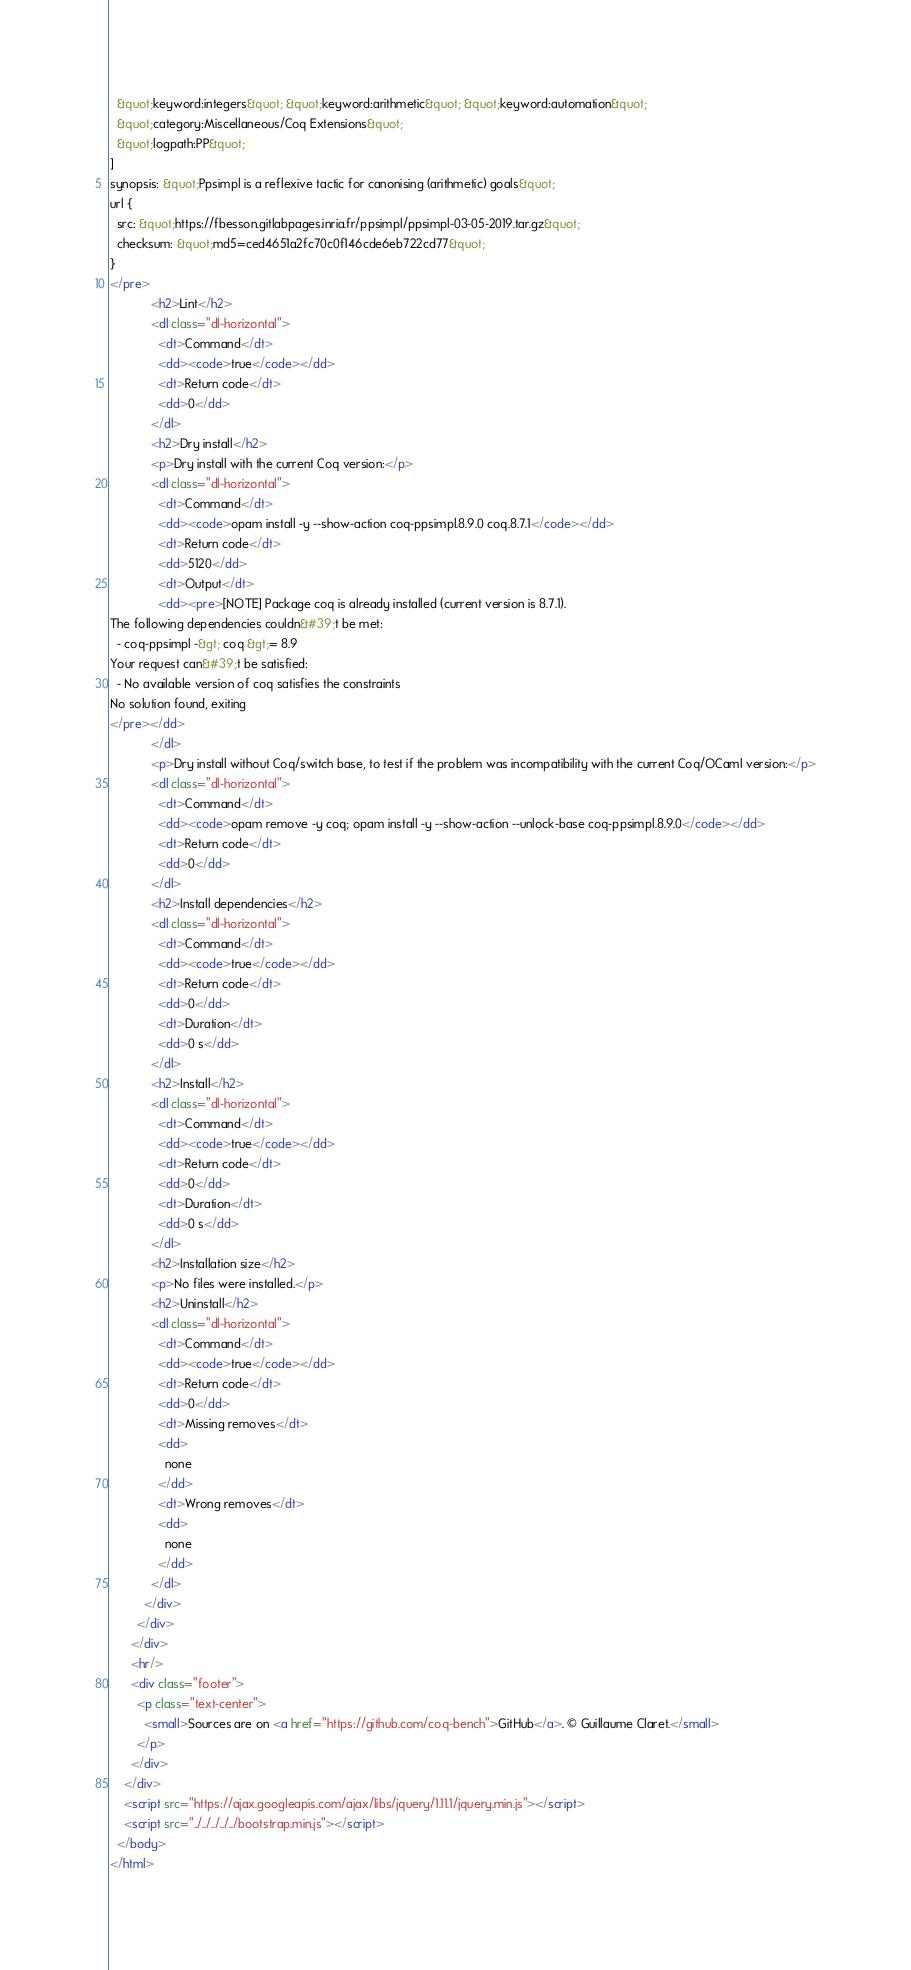Convert code to text. <code><loc_0><loc_0><loc_500><loc_500><_HTML_>  &quot;keyword:integers&quot; &quot;keyword:arithmetic&quot; &quot;keyword:automation&quot;
  &quot;category:Miscellaneous/Coq Extensions&quot;
  &quot;logpath:PP&quot;
]
synopsis: &quot;Ppsimpl is a reflexive tactic for canonising (arithmetic) goals&quot;
url {
  src: &quot;https://fbesson.gitlabpages.inria.fr/ppsimpl/ppsimpl-03-05-2019.tar.gz&quot;
  checksum: &quot;md5=ced4651a2fc70c0f146cde6eb722cd77&quot;
}
</pre>
            <h2>Lint</h2>
            <dl class="dl-horizontal">
              <dt>Command</dt>
              <dd><code>true</code></dd>
              <dt>Return code</dt>
              <dd>0</dd>
            </dl>
            <h2>Dry install</h2>
            <p>Dry install with the current Coq version:</p>
            <dl class="dl-horizontal">
              <dt>Command</dt>
              <dd><code>opam install -y --show-action coq-ppsimpl.8.9.0 coq.8.7.1</code></dd>
              <dt>Return code</dt>
              <dd>5120</dd>
              <dt>Output</dt>
              <dd><pre>[NOTE] Package coq is already installed (current version is 8.7.1).
The following dependencies couldn&#39;t be met:
  - coq-ppsimpl -&gt; coq &gt;= 8.9
Your request can&#39;t be satisfied:
  - No available version of coq satisfies the constraints
No solution found, exiting
</pre></dd>
            </dl>
            <p>Dry install without Coq/switch base, to test if the problem was incompatibility with the current Coq/OCaml version:</p>
            <dl class="dl-horizontal">
              <dt>Command</dt>
              <dd><code>opam remove -y coq; opam install -y --show-action --unlock-base coq-ppsimpl.8.9.0</code></dd>
              <dt>Return code</dt>
              <dd>0</dd>
            </dl>
            <h2>Install dependencies</h2>
            <dl class="dl-horizontal">
              <dt>Command</dt>
              <dd><code>true</code></dd>
              <dt>Return code</dt>
              <dd>0</dd>
              <dt>Duration</dt>
              <dd>0 s</dd>
            </dl>
            <h2>Install</h2>
            <dl class="dl-horizontal">
              <dt>Command</dt>
              <dd><code>true</code></dd>
              <dt>Return code</dt>
              <dd>0</dd>
              <dt>Duration</dt>
              <dd>0 s</dd>
            </dl>
            <h2>Installation size</h2>
            <p>No files were installed.</p>
            <h2>Uninstall</h2>
            <dl class="dl-horizontal">
              <dt>Command</dt>
              <dd><code>true</code></dd>
              <dt>Return code</dt>
              <dd>0</dd>
              <dt>Missing removes</dt>
              <dd>
                none
              </dd>
              <dt>Wrong removes</dt>
              <dd>
                none
              </dd>
            </dl>
          </div>
        </div>
      </div>
      <hr/>
      <div class="footer">
        <p class="text-center">
          <small>Sources are on <a href="https://github.com/coq-bench">GitHub</a>. © Guillaume Claret.</small>
        </p>
      </div>
    </div>
    <script src="https://ajax.googleapis.com/ajax/libs/jquery/1.11.1/jquery.min.js"></script>
    <script src="../../../../../bootstrap.min.js"></script>
  </body>
</html>
</code> 